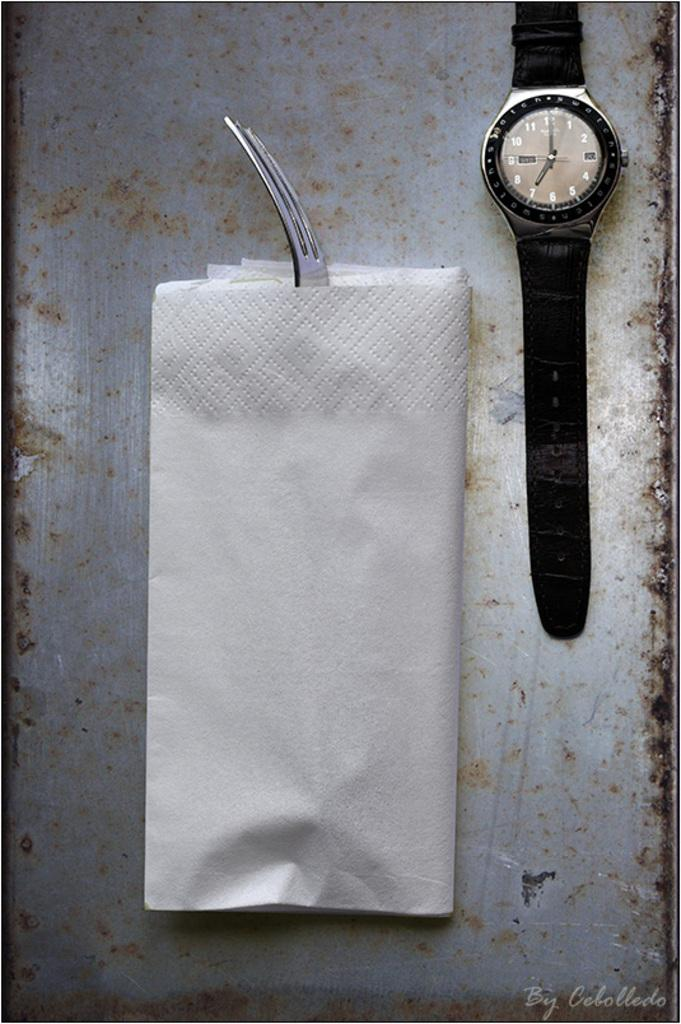<image>
Summarize the visual content of the image. A watch reading seven o`clock sits near a napkin holding a fork. 